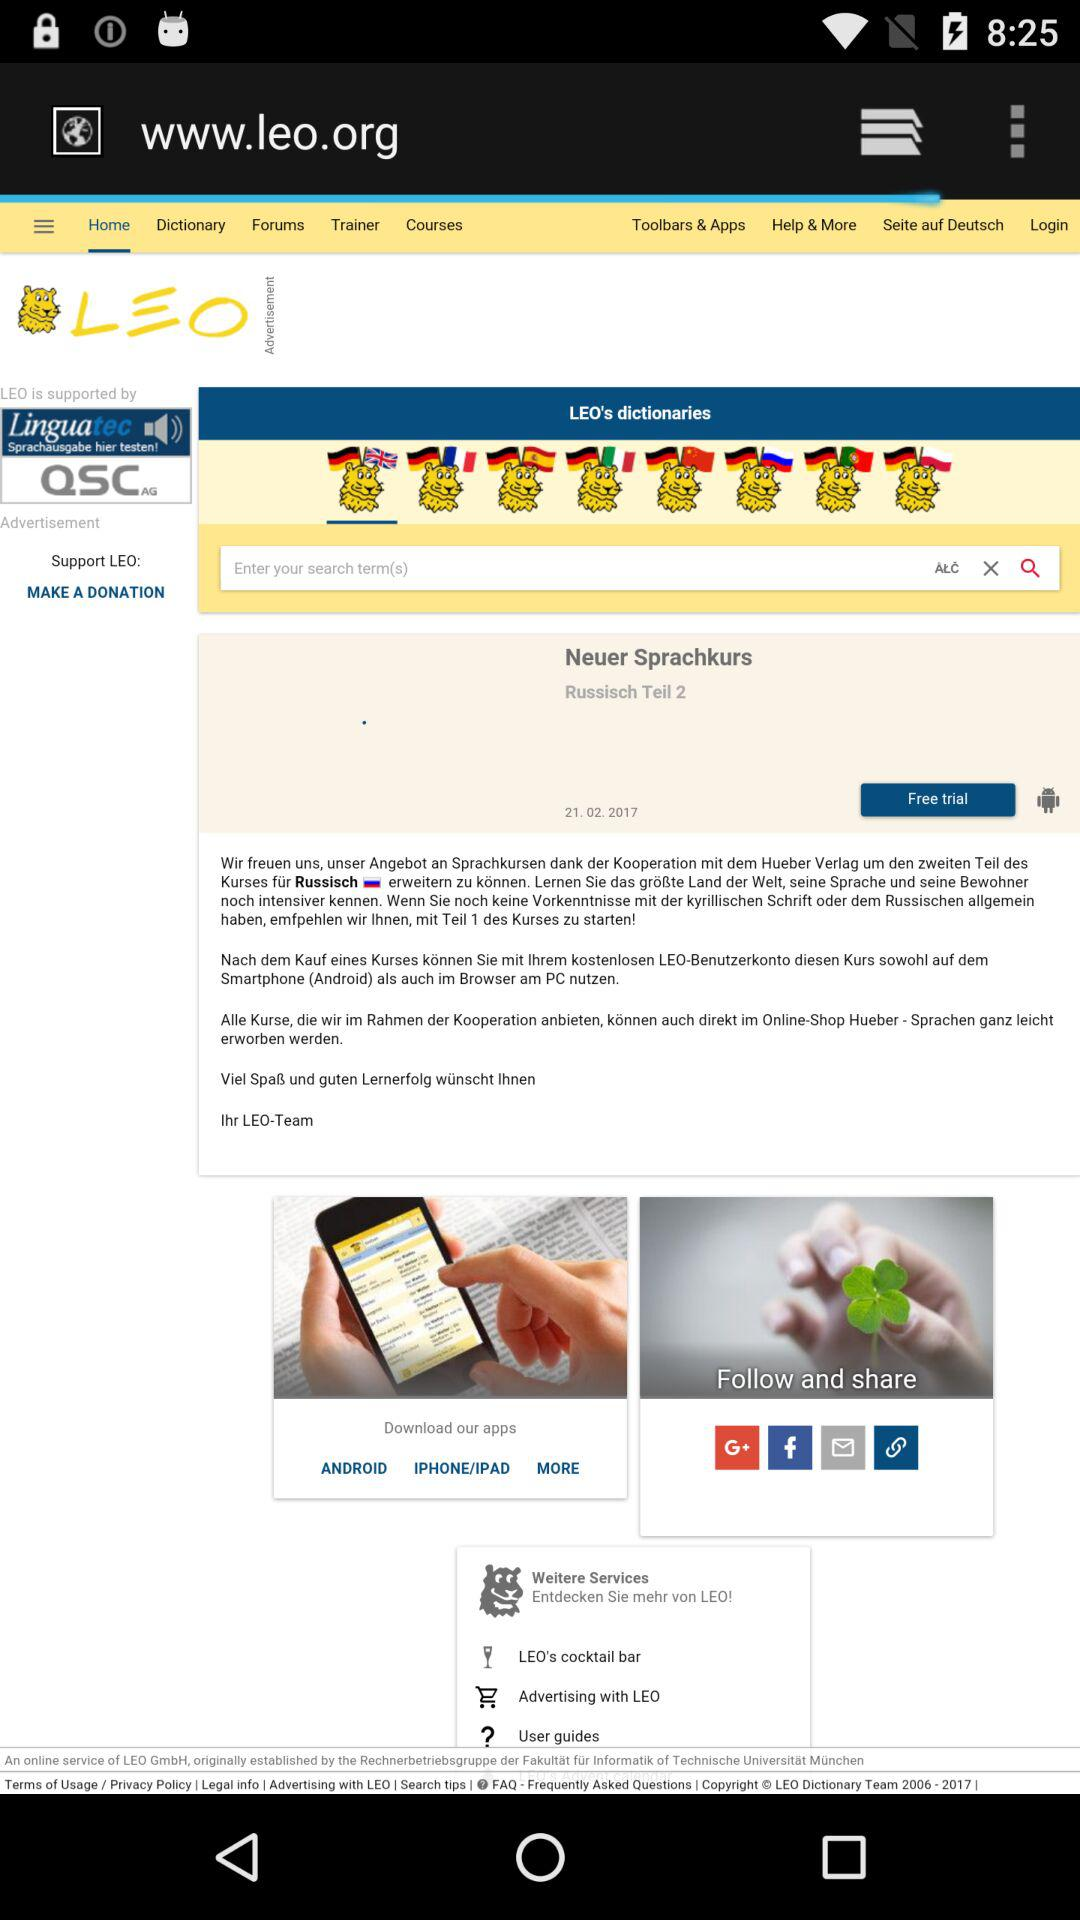Which tab is selected? The selected tab is "Home". 